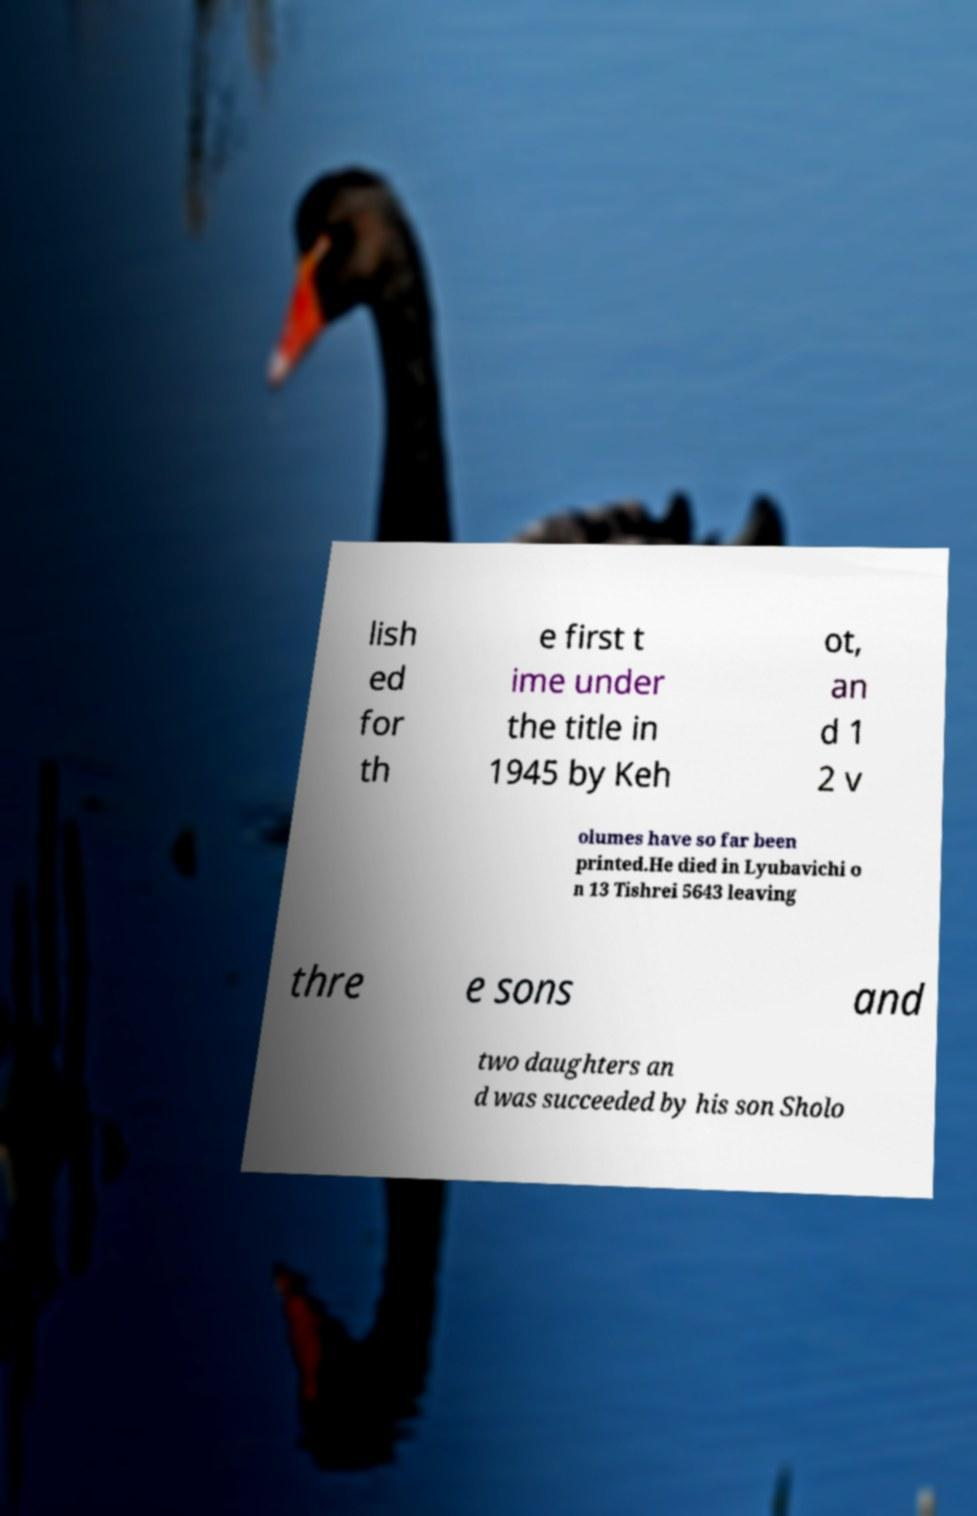Can you accurately transcribe the text from the provided image for me? lish ed for th e first t ime under the title in 1945 by Keh ot, an d 1 2 v olumes have so far been printed.He died in Lyubavichi o n 13 Tishrei 5643 leaving thre e sons and two daughters an d was succeeded by his son Sholo 